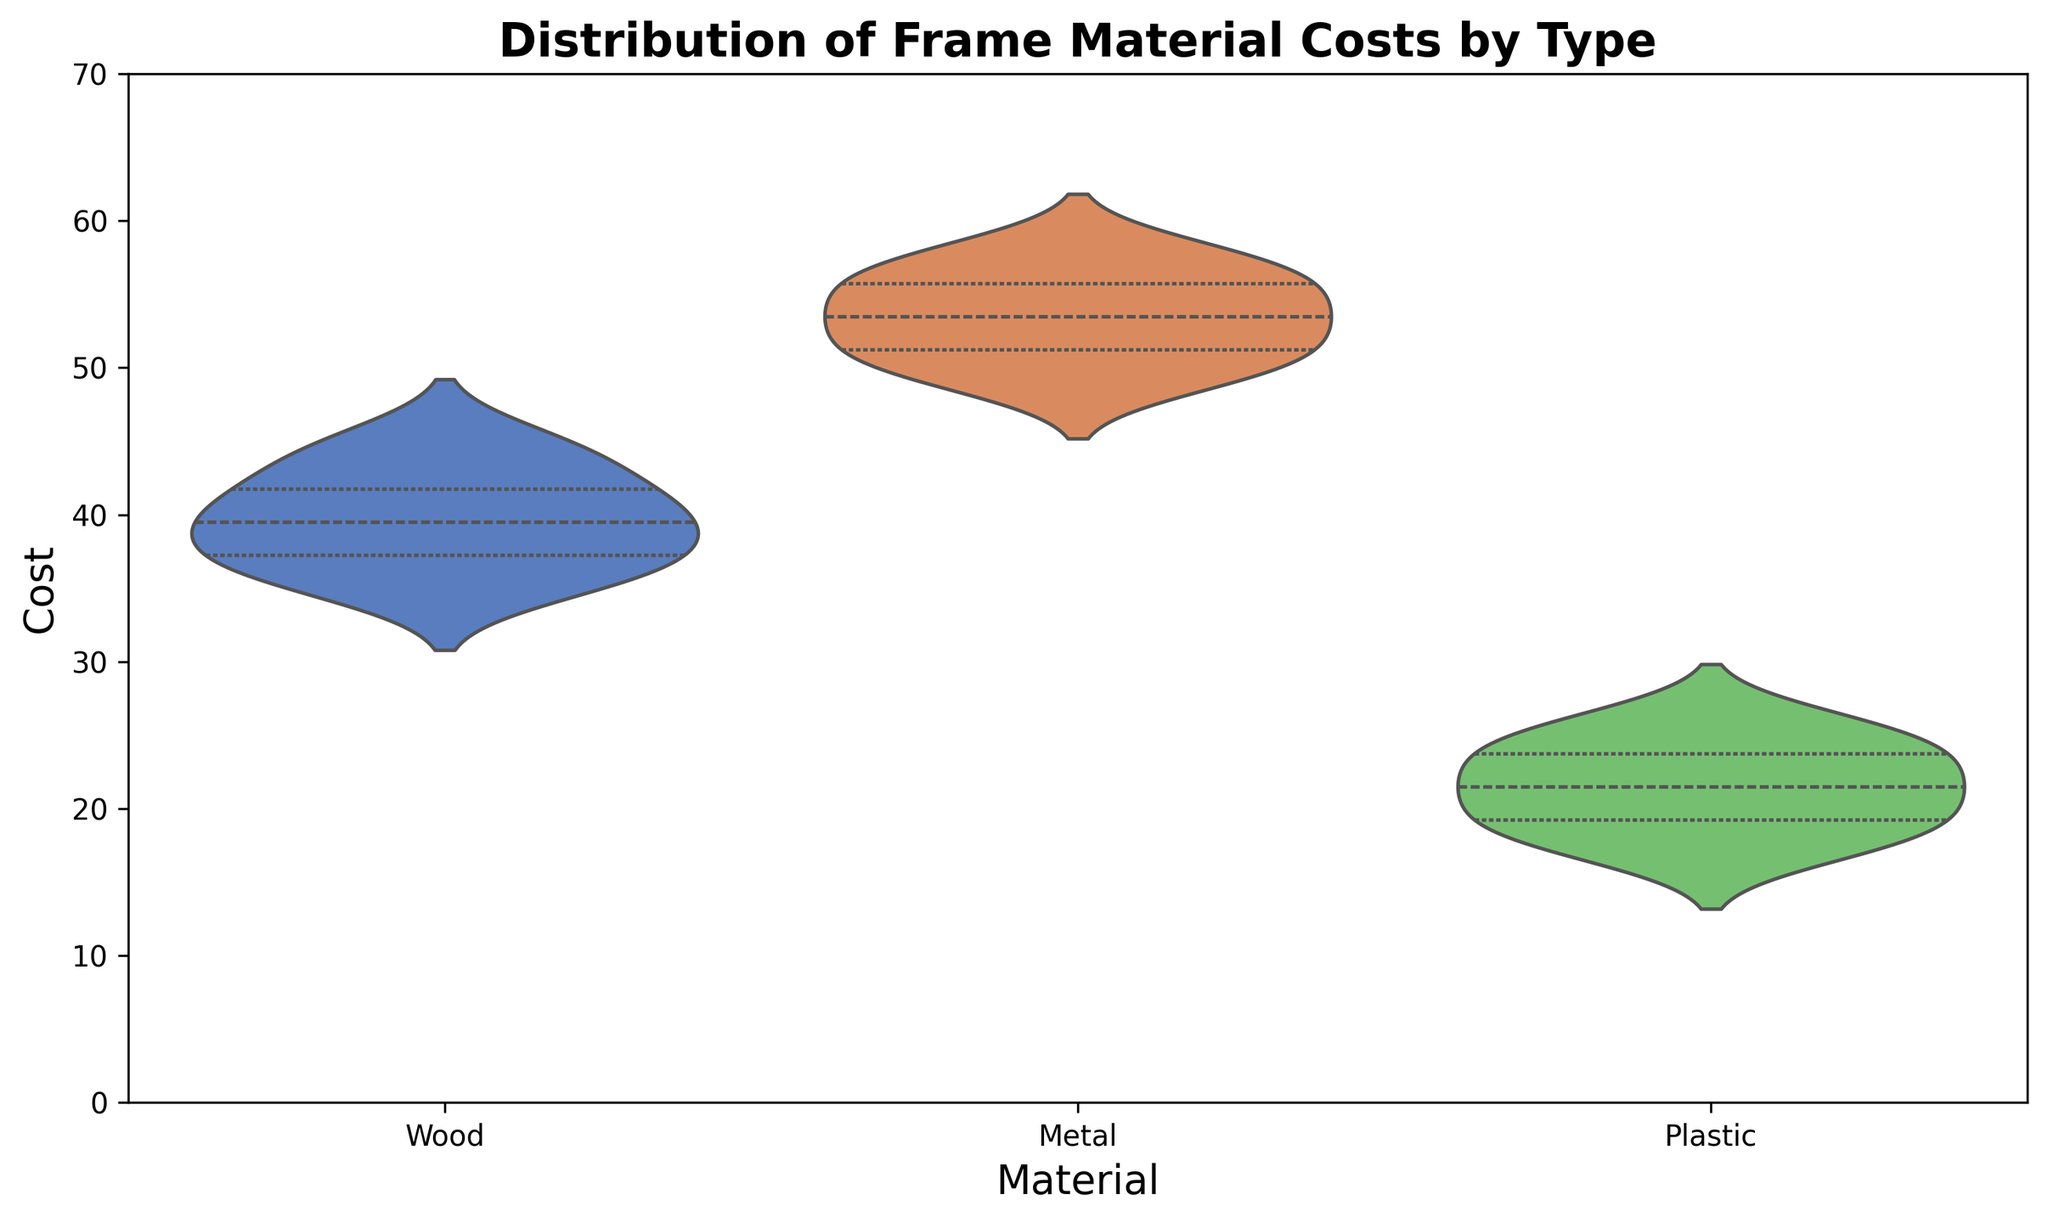What is the median cost of metal frames? The median can be observed from the center point of the inner box within the violin plot for metal frames. Since it divides the lower and upper quartiles, it is approximately the value at the middle line inside the 'Metal' section.
Answer: 54 Which material has the highest cost range? The range of costs can be determined by observing the total spread of the violin plot from the lowest to the highest value. 'Metal' frames show the highest spread from around 49 to 58.
Answer: Metal What is the interquartile range (IQR) for wood frames? The IQR is the range between the first and third quartiles, which can be seen from the width of the 'inner' shaded area in the wood section of the violin plot. This area roughly spans from about 36 to 42.
Answer: 6 Are plastic frames generally cheaper than wood frames? By comparing the median lines inside the violin plots for 'Plastic' and 'Wood', plastic frames have a visibly lower median cost compared to wood frames.
Answer: Yes Can you identify any outliers in the data? Outliers will appear as individual points outside of the smooth shape of the violin plot, especially noticeable when they are separated from the main bulk of data. In this plot, there are no such visible outliers for any material.
Answer: No Which material has the tightest distribution of costs? The tightest distribution will have the narrowest and most compact violin shape. 'Plastic' frames show a very narrow spread compared to 'Wood' and 'Metal'.
Answer: Plastic Between wood and metal, which has a higher upper quartile cost? The upper quartile for each material is the top edge of the inner box of the violin plots. Comparing these, the metal frames' upper quartile is higher than that of the wood frames.
Answer: Metal What is the approximate range of costs for plastic frames? The range can be determined by observing the overall spread of the violin plot for plastic frames. It spans from around 17 to 26.
Answer: 9 Do the wood frame costs have a wider spread compared to plastic frame costs? Comparing the shapes of their plots, wood frames exhibit a broader range of values as the width of the spread (from the bottom to the top) is larger than that of the plastic frames.
Answer: Yes What is the midpoint cost of all materials together? The midpoints can be determined by calculating the average of median costs for each material. Wood roughly around 39, metal 54, and plastic 21. Average of these medians will be (39 + 54 + 21) / 3 = 38.
Answer: 38 